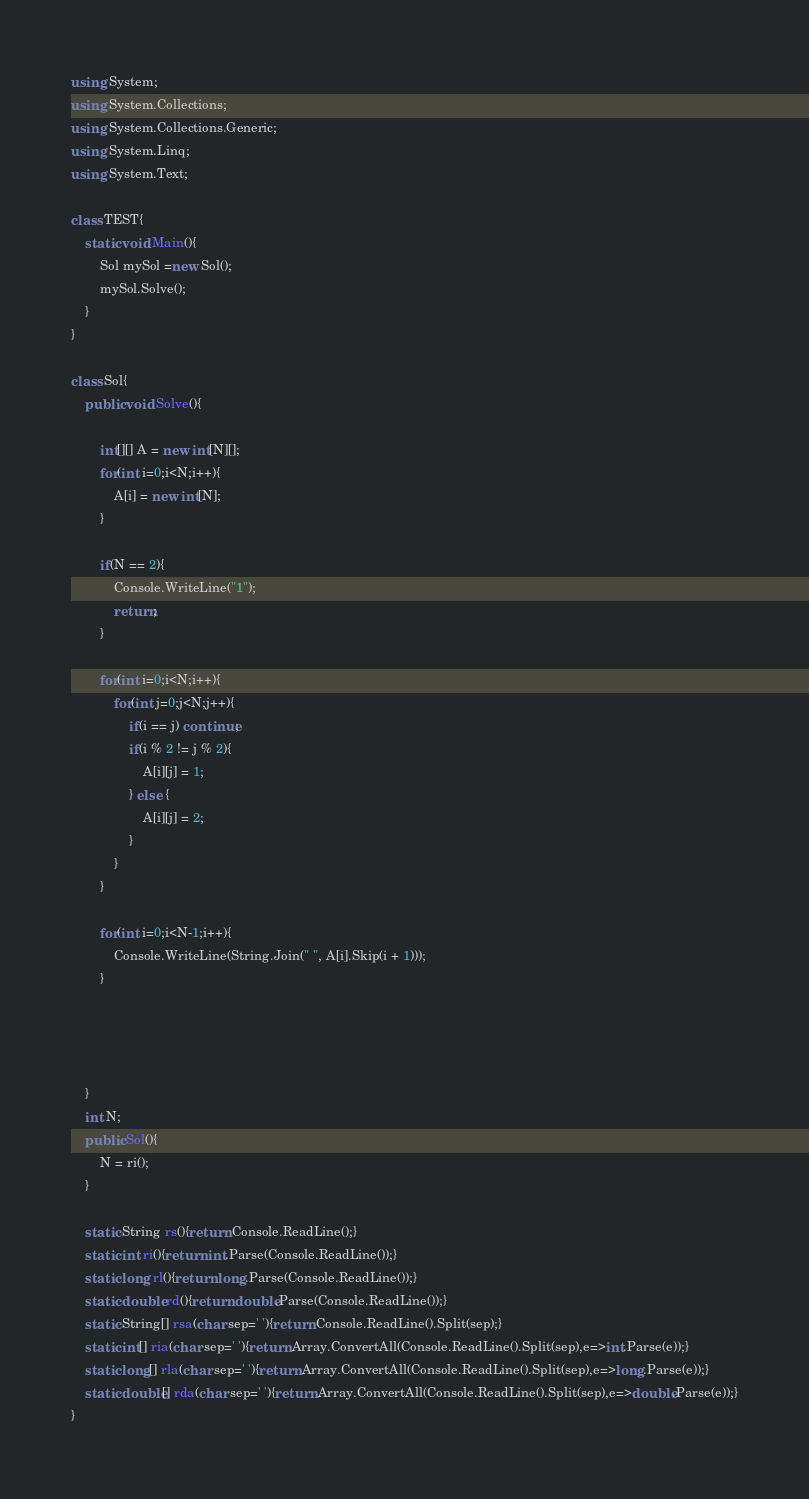<code> <loc_0><loc_0><loc_500><loc_500><_C#_>using System;
using System.Collections;
using System.Collections.Generic;
using System.Linq;
using System.Text;

class TEST{
	static void Main(){
		Sol mySol =new Sol();
		mySol.Solve();
	}
}

class Sol{
	public void Solve(){
		
		int[][] A = new int[N][];
		for(int i=0;i<N;i++){
			A[i] = new int[N];
		}
		
		if(N == 2){
			Console.WriteLine("1");
			return;
		}
		
		for(int i=0;i<N;i++){
			for(int j=0;j<N;j++){
				if(i == j) continue;
				if(i % 2 != j % 2){
					A[i][j] = 1;
				} else {
					A[i][j] = 2;
				}
			}
		}
		
		for(int i=0;i<N-1;i++){
			Console.WriteLine(String.Join(" ", A[i].Skip(i + 1)));
		}
		
		
		
		
	}
	int N;
	public Sol(){
		N = ri();
	}

	static String rs(){return Console.ReadLine();}
	static int ri(){return int.Parse(Console.ReadLine());}
	static long rl(){return long.Parse(Console.ReadLine());}
	static double rd(){return double.Parse(Console.ReadLine());}
	static String[] rsa(char sep=' '){return Console.ReadLine().Split(sep);}
	static int[] ria(char sep=' '){return Array.ConvertAll(Console.ReadLine().Split(sep),e=>int.Parse(e));}
	static long[] rla(char sep=' '){return Array.ConvertAll(Console.ReadLine().Split(sep),e=>long.Parse(e));}
	static double[] rda(char sep=' '){return Array.ConvertAll(Console.ReadLine().Split(sep),e=>double.Parse(e));}
}
</code> 